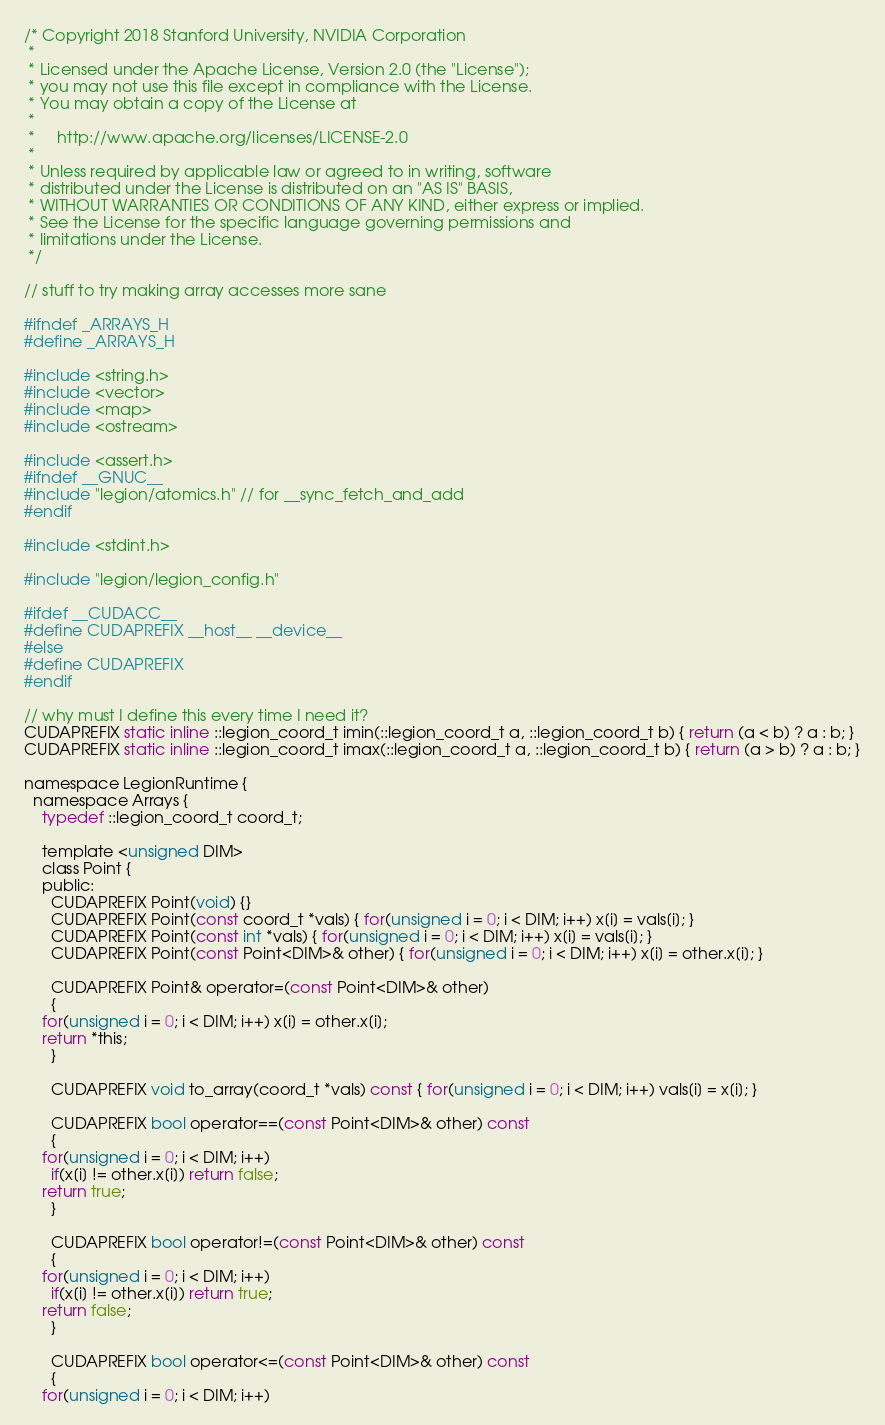<code> <loc_0><loc_0><loc_500><loc_500><_C_>/* Copyright 2018 Stanford University, NVIDIA Corporation
 *
 * Licensed under the Apache License, Version 2.0 (the "License");
 * you may not use this file except in compliance with the License.
 * You may obtain a copy of the License at
 *
 *     http://www.apache.org/licenses/LICENSE-2.0
 *
 * Unless required by applicable law or agreed to in writing, software
 * distributed under the License is distributed on an "AS IS" BASIS,
 * WITHOUT WARRANTIES OR CONDITIONS OF ANY KIND, either express or implied.
 * See the License for the specific language governing permissions and
 * limitations under the License.
 */

// stuff to try making array accesses more sane

#ifndef _ARRAYS_H
#define _ARRAYS_H

#include <string.h>
#include <vector>
#include <map>
#include <ostream>

#include <assert.h>
#ifndef __GNUC__
#include "legion/atomics.h" // for __sync_fetch_and_add
#endif

#include <stdint.h>

#include "legion/legion_config.h"

#ifdef __CUDACC__
#define CUDAPREFIX __host__ __device__
#else
#define CUDAPREFIX
#endif

// why must I define this every time I need it?
CUDAPREFIX static inline ::legion_coord_t imin(::legion_coord_t a, ::legion_coord_t b) { return (a < b) ? a : b; }
CUDAPREFIX static inline ::legion_coord_t imax(::legion_coord_t a, ::legion_coord_t b) { return (a > b) ? a : b; }

namespace LegionRuntime {
  namespace Arrays {
    typedef ::legion_coord_t coord_t;

    template <unsigned DIM>
    class Point {
    public:
      CUDAPREFIX Point(void) {}
      CUDAPREFIX Point(const coord_t *vals) { for(unsigned i = 0; i < DIM; i++) x[i] = vals[i]; }
      CUDAPREFIX Point(const int *vals) { for(unsigned i = 0; i < DIM; i++) x[i] = vals[i]; }
      CUDAPREFIX Point(const Point<DIM>& other) { for(unsigned i = 0; i < DIM; i++) x[i] = other.x[i]; }

      CUDAPREFIX Point& operator=(const Point<DIM>& other) 
      { 
	for(unsigned i = 0; i < DIM; i++) x[i] = other.x[i];
	return *this;
      }

      CUDAPREFIX void to_array(coord_t *vals) const { for(unsigned i = 0; i < DIM; i++) vals[i] = x[i]; }

      CUDAPREFIX bool operator==(const Point<DIM>& other) const
      { 
	for(unsigned i = 0; i < DIM; i++) 
	  if(x[i] != other.x[i]) return false; 
	return true; 
      }

      CUDAPREFIX bool operator!=(const Point<DIM>& other) const
      { 
	for(unsigned i = 0; i < DIM; i++) 
	  if(x[i] != other.x[i]) return true; 
	return false; 
      }

      CUDAPREFIX bool operator<=(const Point<DIM>& other) const
      { 
	for(unsigned i = 0; i < DIM; i++) </code> 